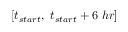<formula> <loc_0><loc_0><loc_500><loc_500>[ t _ { s t a r t } , t _ { s t a r t } + 6 h r ]</formula> 